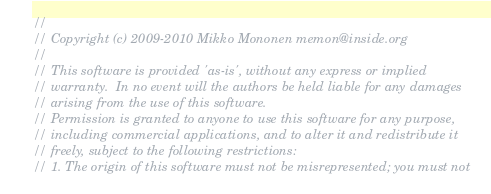<code> <loc_0><loc_0><loc_500><loc_500><_C++_>//
// Copyright (c) 2009-2010 Mikko Mononen memon@inside.org
//
// This software is provided 'as-is', without any express or implied
// warranty.  In no event will the authors be held liable for any damages
// arising from the use of this software.
// Permission is granted to anyone to use this software for any purpose,
// including commercial applications, and to alter it and redistribute it
// freely, subject to the following restrictions:
// 1. The origin of this software must not be misrepresented; you must not</code> 